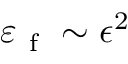<formula> <loc_0><loc_0><loc_500><loc_500>\varepsilon _ { f } \sim \epsilon ^ { 2 }</formula> 